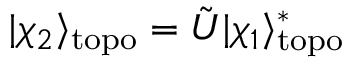<formula> <loc_0><loc_0><loc_500><loc_500>| \chi _ { 2 } \rangle _ { t o p o } = \tilde { U } | \chi _ { 1 } \rangle _ { t o p o } ^ { * }</formula> 